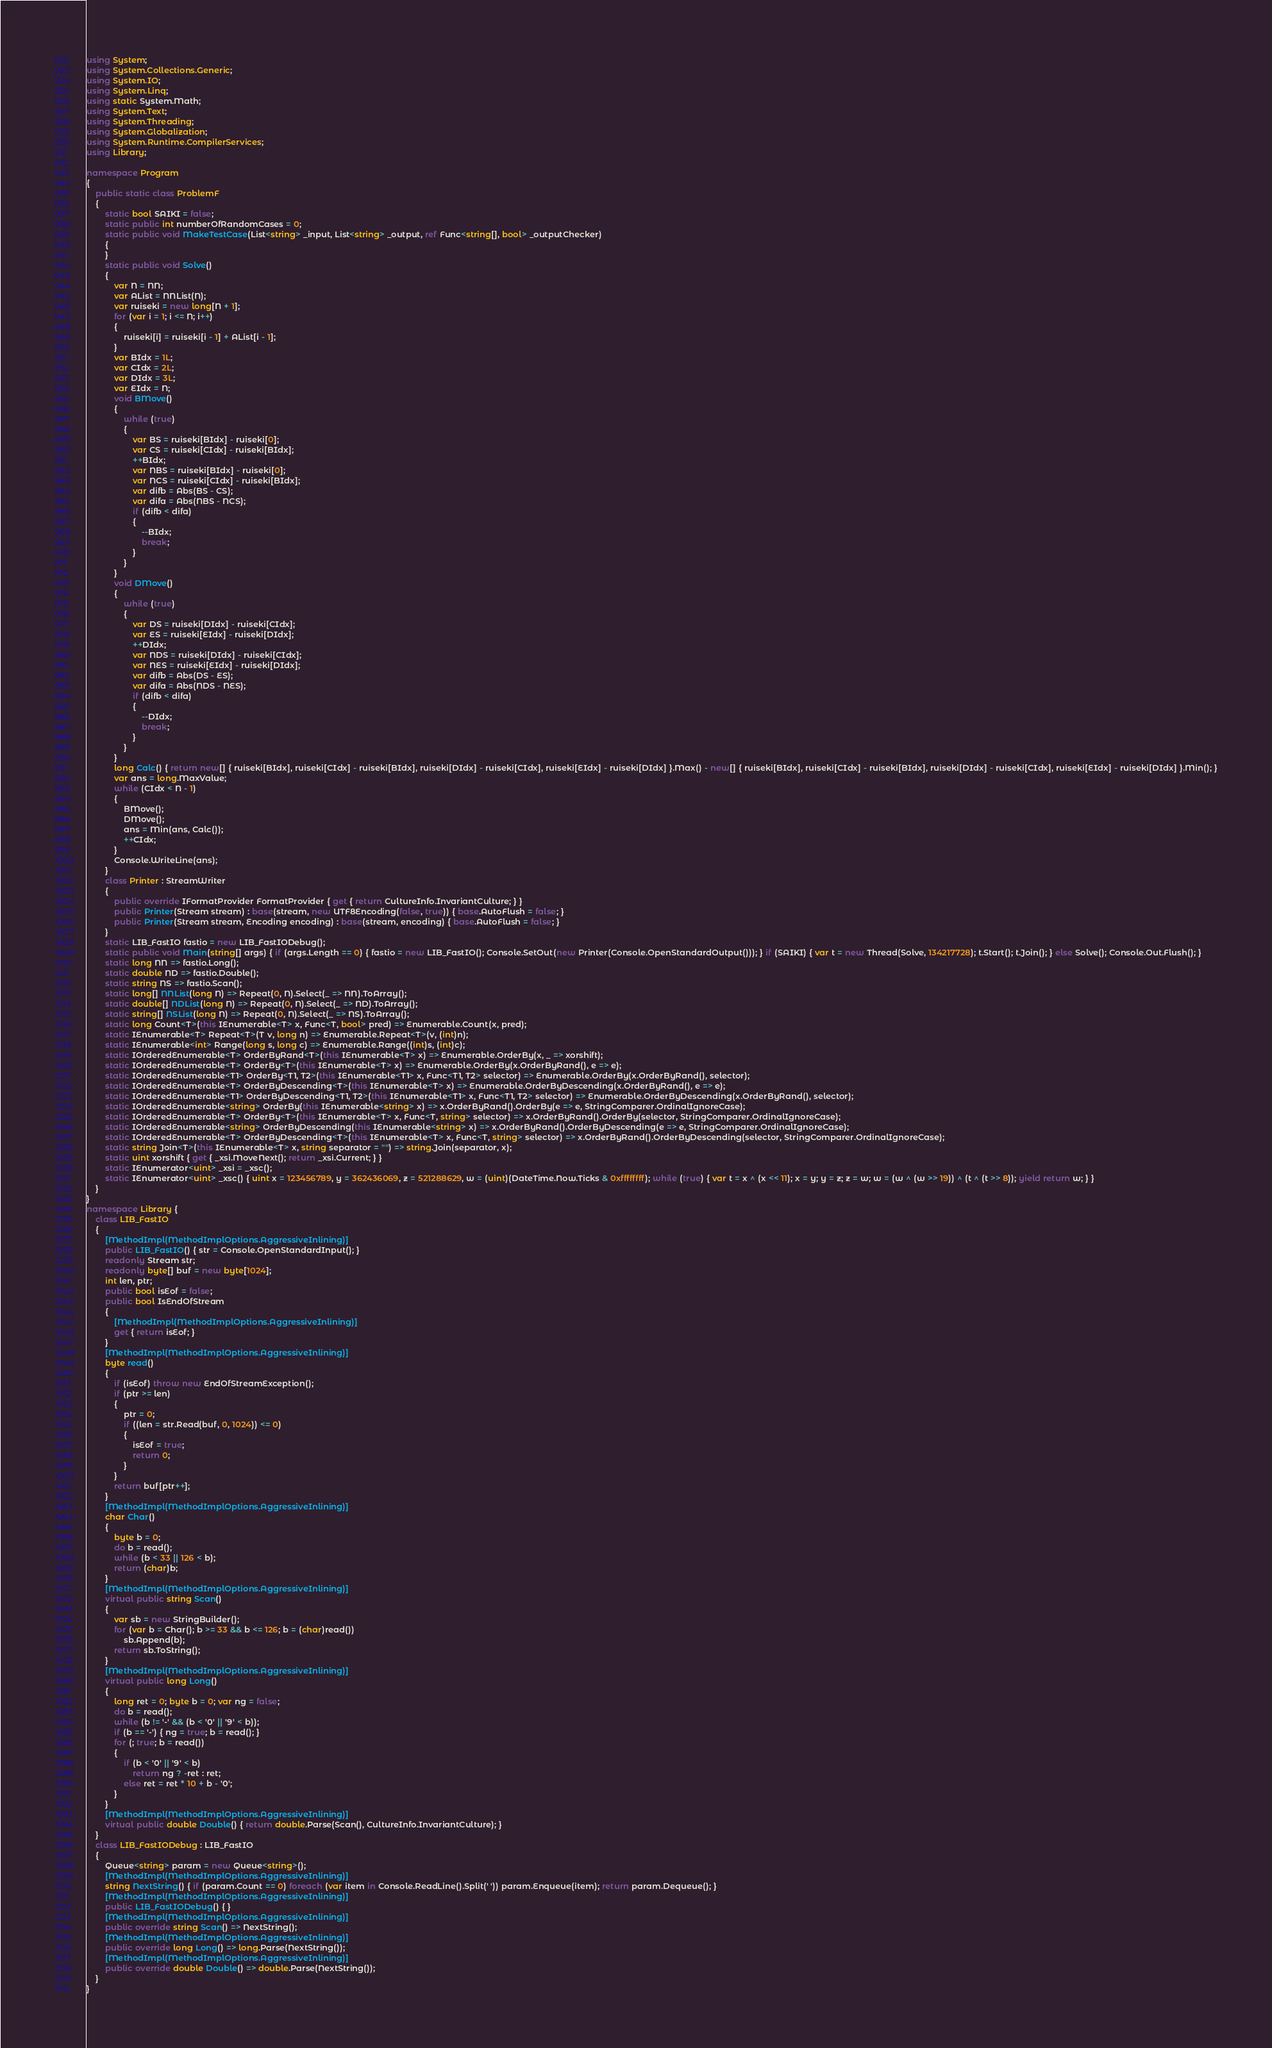<code> <loc_0><loc_0><loc_500><loc_500><_C#_>using System;
using System.Collections.Generic;
using System.IO;
using System.Linq;
using static System.Math;
using System.Text;
using System.Threading;
using System.Globalization;
using System.Runtime.CompilerServices;
using Library;

namespace Program
{
    public static class ProblemF
    {
        static bool SAIKI = false;
        static public int numberOfRandomCases = 0;
        static public void MakeTestCase(List<string> _input, List<string> _output, ref Func<string[], bool> _outputChecker)
        {
        }
        static public void Solve()
        {
            var N = NN;
            var AList = NNList(N);
            var ruiseki = new long[N + 1];
            for (var i = 1; i <= N; i++)
            {
                ruiseki[i] = ruiseki[i - 1] + AList[i - 1];
            }
            var BIdx = 1L;
            var CIdx = 2L;
            var DIdx = 3L;
            var EIdx = N;
            void BMove()
            {
                while (true)
                {
                    var BS = ruiseki[BIdx] - ruiseki[0];
                    var CS = ruiseki[CIdx] - ruiseki[BIdx];
                    ++BIdx;
                    var NBS = ruiseki[BIdx] - ruiseki[0];
                    var NCS = ruiseki[CIdx] - ruiseki[BIdx];
                    var difb = Abs(BS - CS);
                    var difa = Abs(NBS - NCS);
                    if (difb < difa)
                    {
                        --BIdx;
                        break;
                    }
                }
            }
            void DMove()
            {
                while (true)
                {
                    var DS = ruiseki[DIdx] - ruiseki[CIdx];
                    var ES = ruiseki[EIdx] - ruiseki[DIdx];
                    ++DIdx;
                    var NDS = ruiseki[DIdx] - ruiseki[CIdx];
                    var NES = ruiseki[EIdx] - ruiseki[DIdx];
                    var difb = Abs(DS - ES);
                    var difa = Abs(NDS - NES);
                    if (difb < difa)
                    {
                        --DIdx;
                        break;
                    }
                }
            }
            long Calc() { return new[] { ruiseki[BIdx], ruiseki[CIdx] - ruiseki[BIdx], ruiseki[DIdx] - ruiseki[CIdx], ruiseki[EIdx] - ruiseki[DIdx] }.Max() - new[] { ruiseki[BIdx], ruiseki[CIdx] - ruiseki[BIdx], ruiseki[DIdx] - ruiseki[CIdx], ruiseki[EIdx] - ruiseki[DIdx] }.Min(); }
            var ans = long.MaxValue;
            while (CIdx < N - 1)
            {
                BMove();
                DMove();
                ans = Min(ans, Calc());
                ++CIdx;
            }
            Console.WriteLine(ans);
        }
        class Printer : StreamWriter
        {
            public override IFormatProvider FormatProvider { get { return CultureInfo.InvariantCulture; } }
            public Printer(Stream stream) : base(stream, new UTF8Encoding(false, true)) { base.AutoFlush = false; }
            public Printer(Stream stream, Encoding encoding) : base(stream, encoding) { base.AutoFlush = false; }
        }
        static LIB_FastIO fastio = new LIB_FastIODebug();
        static public void Main(string[] args) { if (args.Length == 0) { fastio = new LIB_FastIO(); Console.SetOut(new Printer(Console.OpenStandardOutput())); } if (SAIKI) { var t = new Thread(Solve, 134217728); t.Start(); t.Join(); } else Solve(); Console.Out.Flush(); }
        static long NN => fastio.Long();
        static double ND => fastio.Double();
        static string NS => fastio.Scan();
        static long[] NNList(long N) => Repeat(0, N).Select(_ => NN).ToArray();
        static double[] NDList(long N) => Repeat(0, N).Select(_ => ND).ToArray();
        static string[] NSList(long N) => Repeat(0, N).Select(_ => NS).ToArray();
        static long Count<T>(this IEnumerable<T> x, Func<T, bool> pred) => Enumerable.Count(x, pred);
        static IEnumerable<T> Repeat<T>(T v, long n) => Enumerable.Repeat<T>(v, (int)n);
        static IEnumerable<int> Range(long s, long c) => Enumerable.Range((int)s, (int)c);
        static IOrderedEnumerable<T> OrderByRand<T>(this IEnumerable<T> x) => Enumerable.OrderBy(x, _ => xorshift);
        static IOrderedEnumerable<T> OrderBy<T>(this IEnumerable<T> x) => Enumerable.OrderBy(x.OrderByRand(), e => e);
        static IOrderedEnumerable<T1> OrderBy<T1, T2>(this IEnumerable<T1> x, Func<T1, T2> selector) => Enumerable.OrderBy(x.OrderByRand(), selector);
        static IOrderedEnumerable<T> OrderByDescending<T>(this IEnumerable<T> x) => Enumerable.OrderByDescending(x.OrderByRand(), e => e);
        static IOrderedEnumerable<T1> OrderByDescending<T1, T2>(this IEnumerable<T1> x, Func<T1, T2> selector) => Enumerable.OrderByDescending(x.OrderByRand(), selector);
        static IOrderedEnumerable<string> OrderBy(this IEnumerable<string> x) => x.OrderByRand().OrderBy(e => e, StringComparer.OrdinalIgnoreCase);
        static IOrderedEnumerable<T> OrderBy<T>(this IEnumerable<T> x, Func<T, string> selector) => x.OrderByRand().OrderBy(selector, StringComparer.OrdinalIgnoreCase);
        static IOrderedEnumerable<string> OrderByDescending(this IEnumerable<string> x) => x.OrderByRand().OrderByDescending(e => e, StringComparer.OrdinalIgnoreCase);
        static IOrderedEnumerable<T> OrderByDescending<T>(this IEnumerable<T> x, Func<T, string> selector) => x.OrderByRand().OrderByDescending(selector, StringComparer.OrdinalIgnoreCase);
        static string Join<T>(this IEnumerable<T> x, string separator = "") => string.Join(separator, x);
        static uint xorshift { get { _xsi.MoveNext(); return _xsi.Current; } }
        static IEnumerator<uint> _xsi = _xsc();
        static IEnumerator<uint> _xsc() { uint x = 123456789, y = 362436069, z = 521288629, w = (uint)(DateTime.Now.Ticks & 0xffffffff); while (true) { var t = x ^ (x << 11); x = y; y = z; z = w; w = (w ^ (w >> 19)) ^ (t ^ (t >> 8)); yield return w; } }
    }
}
namespace Library {
    class LIB_FastIO
    {
        [MethodImpl(MethodImplOptions.AggressiveInlining)]
        public LIB_FastIO() { str = Console.OpenStandardInput(); }
        readonly Stream str;
        readonly byte[] buf = new byte[1024];
        int len, ptr;
        public bool isEof = false;
        public bool IsEndOfStream
        {
            [MethodImpl(MethodImplOptions.AggressiveInlining)]
            get { return isEof; }
        }
        [MethodImpl(MethodImplOptions.AggressiveInlining)]
        byte read()
        {
            if (isEof) throw new EndOfStreamException();
            if (ptr >= len)
            {
                ptr = 0;
                if ((len = str.Read(buf, 0, 1024)) <= 0)
                {
                    isEof = true;
                    return 0;
                }
            }
            return buf[ptr++];
        }
        [MethodImpl(MethodImplOptions.AggressiveInlining)]
        char Char()
        {
            byte b = 0;
            do b = read();
            while (b < 33 || 126 < b);
            return (char)b;
        }
        [MethodImpl(MethodImplOptions.AggressiveInlining)]
        virtual public string Scan()
        {
            var sb = new StringBuilder();
            for (var b = Char(); b >= 33 && b <= 126; b = (char)read())
                sb.Append(b);
            return sb.ToString();
        }
        [MethodImpl(MethodImplOptions.AggressiveInlining)]
        virtual public long Long()
        {
            long ret = 0; byte b = 0; var ng = false;
            do b = read();
            while (b != '-' && (b < '0' || '9' < b));
            if (b == '-') { ng = true; b = read(); }
            for (; true; b = read())
            {
                if (b < '0' || '9' < b)
                    return ng ? -ret : ret;
                else ret = ret * 10 + b - '0';
            }
        }
        [MethodImpl(MethodImplOptions.AggressiveInlining)]
        virtual public double Double() { return double.Parse(Scan(), CultureInfo.InvariantCulture); }
    }
    class LIB_FastIODebug : LIB_FastIO
    {
        Queue<string> param = new Queue<string>();
        [MethodImpl(MethodImplOptions.AggressiveInlining)]
        string NextString() { if (param.Count == 0) foreach (var item in Console.ReadLine().Split(' ')) param.Enqueue(item); return param.Dequeue(); }
        [MethodImpl(MethodImplOptions.AggressiveInlining)]
        public LIB_FastIODebug() { }
        [MethodImpl(MethodImplOptions.AggressiveInlining)]
        public override string Scan() => NextString();
        [MethodImpl(MethodImplOptions.AggressiveInlining)]
        public override long Long() => long.Parse(NextString());
        [MethodImpl(MethodImplOptions.AggressiveInlining)]
        public override double Double() => double.Parse(NextString());
    }
}
</code> 